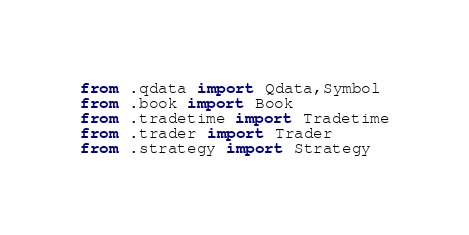<code> <loc_0><loc_0><loc_500><loc_500><_Python_>from .qdata import Qdata,Symbol
from .book import Book
from .tradetime import Tradetime
from .trader import Trader
from .strategy import Strategy</code> 